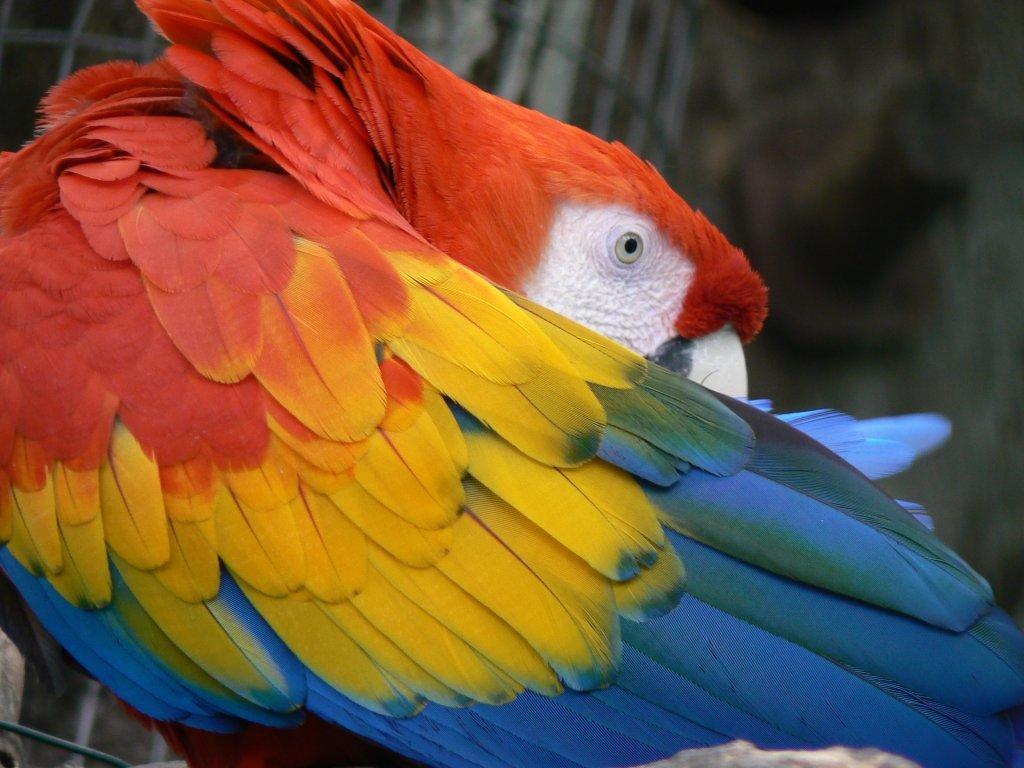How would you summarize this image in a sentence or two? In this image I can see a bird. And the background is blurry. 